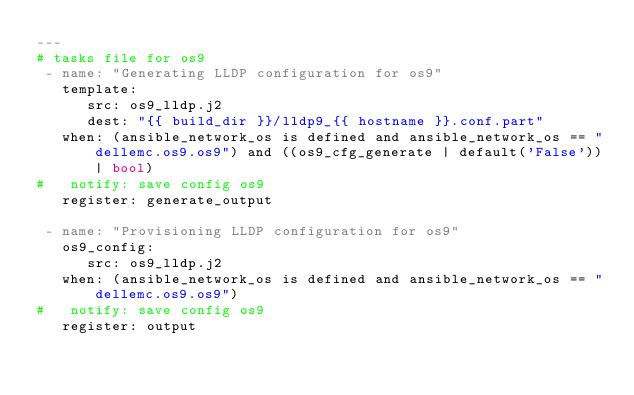Convert code to text. <code><loc_0><loc_0><loc_500><loc_500><_YAML_>---
# tasks file for os9
 - name: "Generating LLDP configuration for os9"
   template:
      src: os9_lldp.j2
      dest: "{{ build_dir }}/lldp9_{{ hostname }}.conf.part"
   when: (ansible_network_os is defined and ansible_network_os == "dellemc.os9.os9") and ((os9_cfg_generate | default('False'))| bool)
#   notify: save config os9
   register: generate_output

 - name: "Provisioning LLDP configuration for os9"
   os9_config:
      src: os9_lldp.j2
   when: (ansible_network_os is defined and ansible_network_os == "dellemc.os9.os9")
#   notify: save config os9
   register: output</code> 